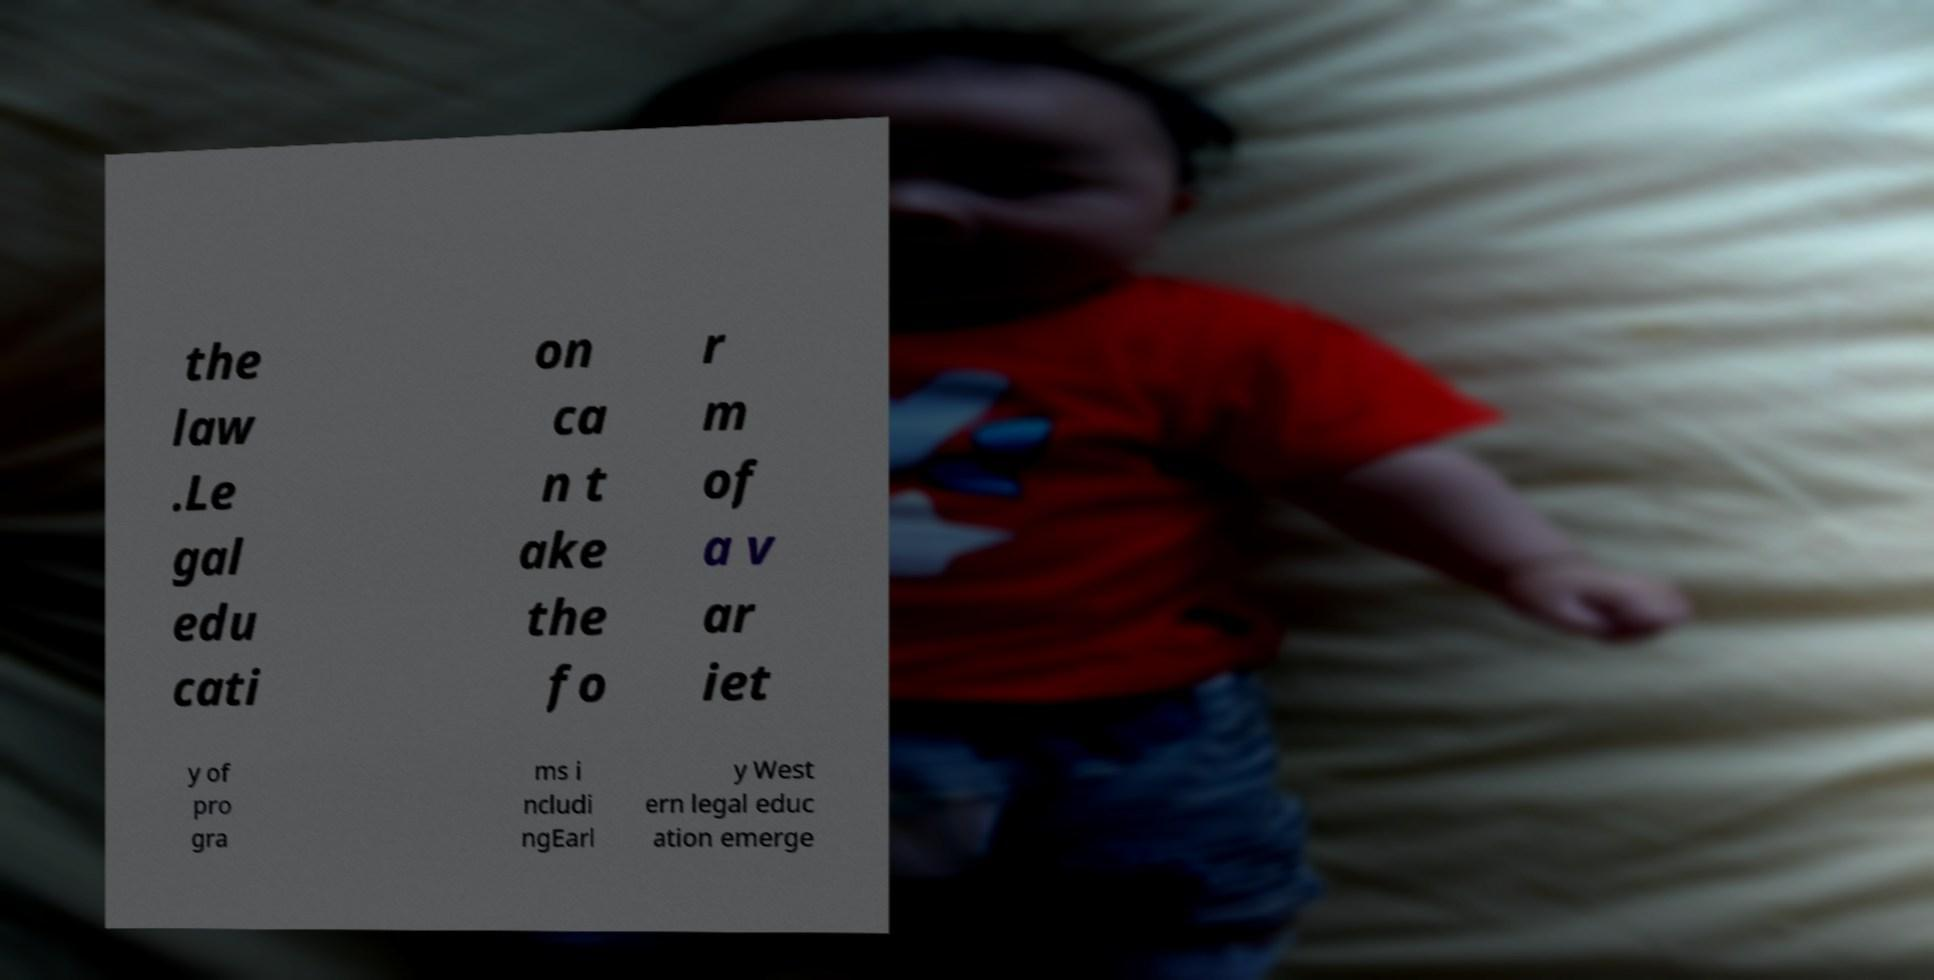Please identify and transcribe the text found in this image. the law .Le gal edu cati on ca n t ake the fo r m of a v ar iet y of pro gra ms i ncludi ngEarl y West ern legal educ ation emerge 